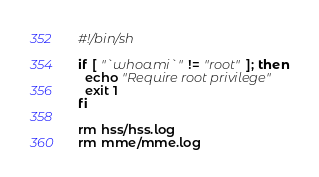<code> <loc_0><loc_0><loc_500><loc_500><_Bash_>#!/bin/sh

if [ "`whoami`" != "root" ]; then
  echo "Require root privilege"
  exit 1
fi

rm hss/hss.log
rm mme/mme.log</code> 